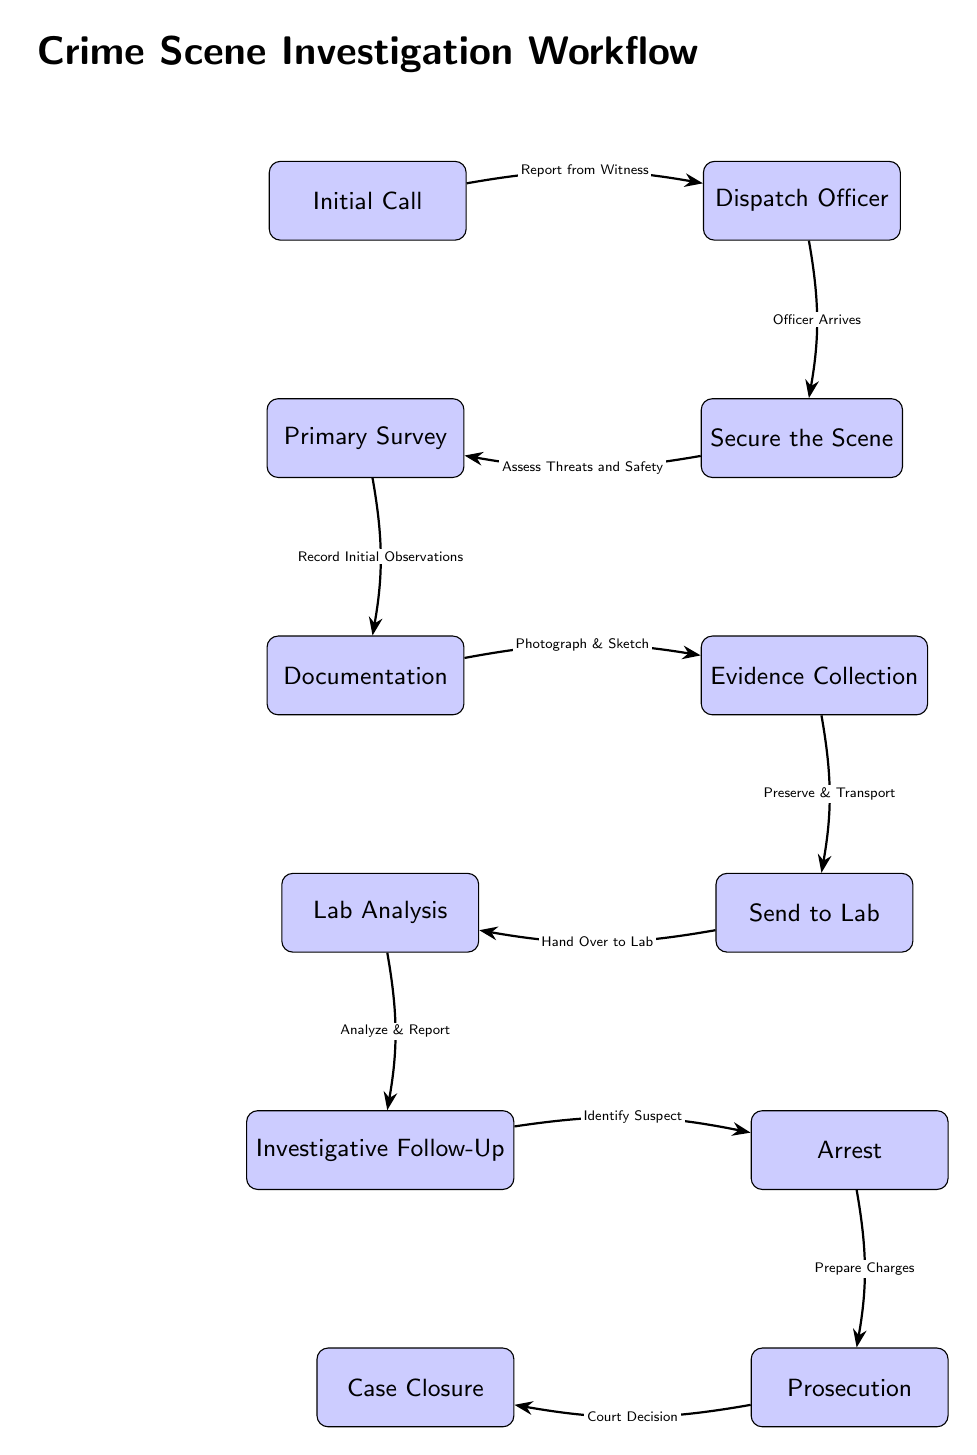What is the first step in the crime scene investigation workflow? The first step is indicated by the initial node in the diagram, which states "Initial Call." This is where the investigation begins based on a report.
Answer: Initial Call How many nodes are in the diagram? By counting all the distinct blocks represented in the diagram from "Initial Call" to "Case Closure," there are 11 nodes total.
Answer: 11 What action follows 'Secure the Scene'? The diagram illustrates that after the officer secures the scene, the next action is "Primary Survey." This step involves assessing the location for immediate threats.
Answer: Primary Survey What is the relationship between 'Evidence Collection' and 'Lab Analysis'? The diagram shows a direct flow from "Evidence Collection" to "Lab Analysis," with the action labeled as "Send to Lab." This indicates that collected evidence is sent for laboratory analysis next.
Answer: Send to Lab At what point in the process is the "Court Decision" made? The "Court Decision" occurs after the "Prosecution" step, as indicated by the arrows that demonstrate the workflow, leading to "Case Closure."
Answer: Prosecution What is the final step in the crime scene investigation workflow? The last block in the workflow diagram is labeled "Case Closure," which signifies completing the investigation process.
Answer: Case Closure Which step comes after conducting "Lab Analysis"? Following the analysis conducted in the lab, the workflow proceeds to "Investigative Follow-Up," where results guide further investigation.
Answer: Investigative Follow-Up What document must be prepared after an arrest? In the workflow, after making an arrest, the next required step is to "Prepare Charges," as shown in the sequence.
Answer: Prepare Charges How does evidence collection contribute to the overall investigation workflow? Evidence collection is essential to the workflow. After "Documentation," it leads to "Send to Lab," indicating a sequence where collected evidence is vital for subsequent investigative actions, making it a critical step.
Answer: Evidence Collection 